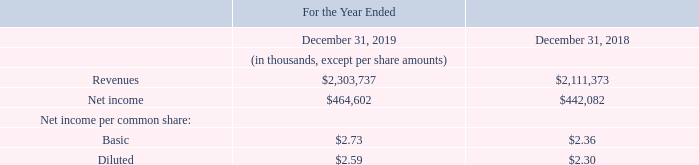Pro Forma Information
The following unaudited pro forma information gives effect to the acquisition of AutoGuide as if the acquisition occurred on January 1, 2018 and the acquisition of MiR as if the acquisition occurred on January 1, 2017. The unaudited pro forma results are not necessarily indicative of what actually would have occurred had the acquisition been in effect for the periods presented:
Pro forma results for the year ended December 31, 2019 were adjusted to exclude $1.2 million of AutoGuide acquisition related costs and $0.1 million of AutoGuide non-recurring expense related to fair value adjustment to acquisition-date inventory.
Pro forma results for the year ended December 31, 2018 were adjusted to include $1.2 million of AutoGuide acquisition related costs and $0.4 million of AutoGuide non-recurring expense related to fair value adjustment to acquisition-date inventory.
Pro forma results for the year ended December 31, 2018 were adjusted to exclude $2.9 million of MiR acquisition related costs and $0.4 million of MiR non-recurring expense related to fair value adjustment to acquisition-date inventory.
What were the Pro forma results for the year ended December 31, 2019 adjusted for? Adjusted to exclude $1.2 million of autoguide acquisition related costs and $0.1 million of autoguide non-recurring expense related to fair value adjustment to acquisition-date inventory. What was the net income in 2019?
Answer scale should be: thousand. $464,602. What are the types of net income per common share in the table? Basic, diluted. In which year was diluted net income per common share larger? 2.59>2.30
Answer: 2019. What was the change in diluted net income per common share from 2018 to 2019? 2.59-2.30
Answer: 0.29. What was the percentage change in diluted net income per common share from 2018 to 2019?
Answer scale should be: percent. (2.59-2.30)/2.30
Answer: 12.61. 